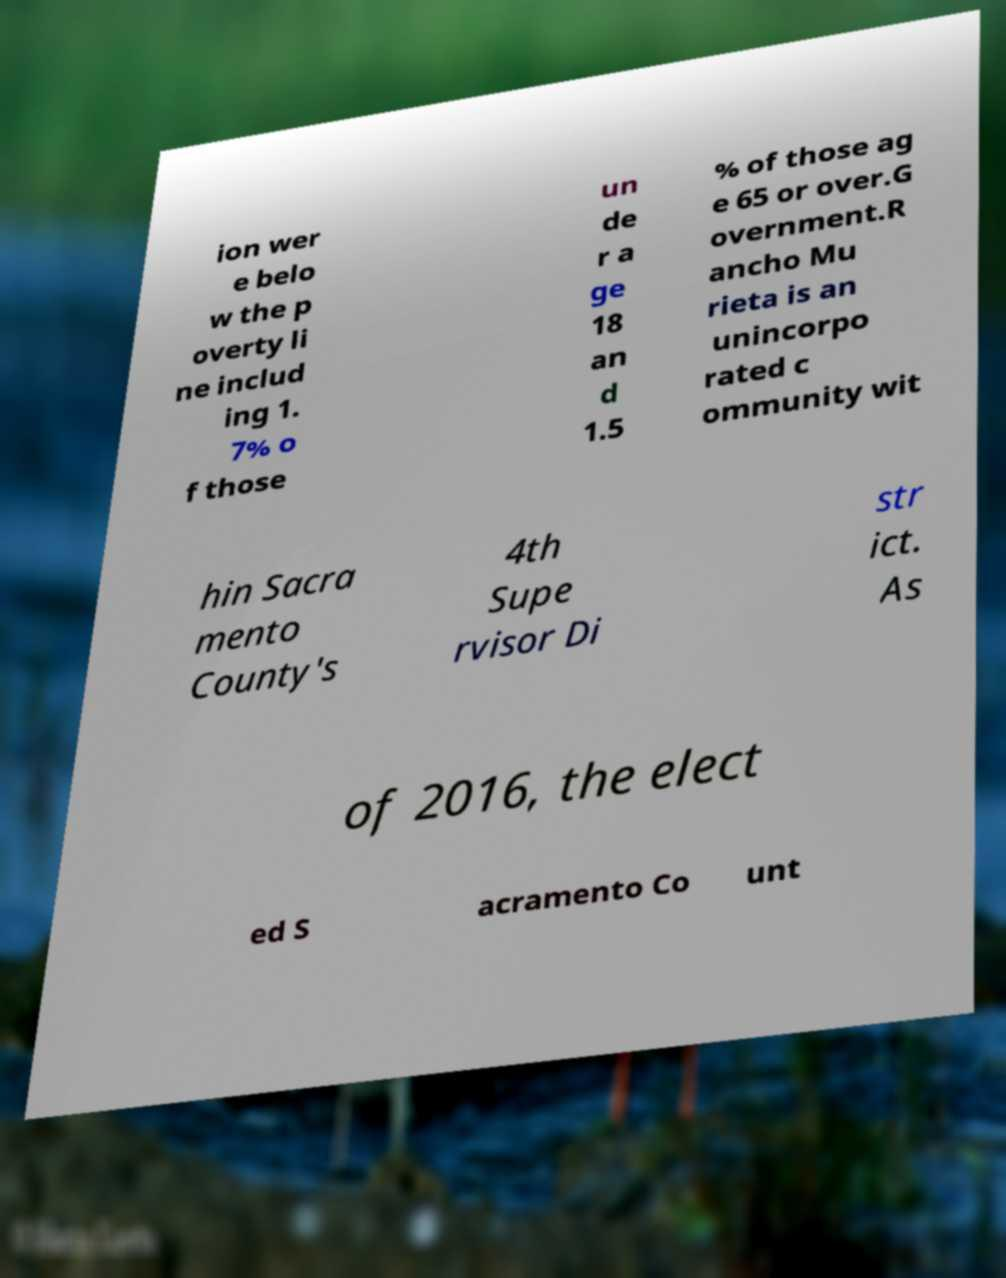Please read and relay the text visible in this image. What does it say? ion wer e belo w the p overty li ne includ ing 1. 7% o f those un de r a ge 18 an d 1.5 % of those ag e 65 or over.G overnment.R ancho Mu rieta is an unincorpo rated c ommunity wit hin Sacra mento County's 4th Supe rvisor Di str ict. As of 2016, the elect ed S acramento Co unt 